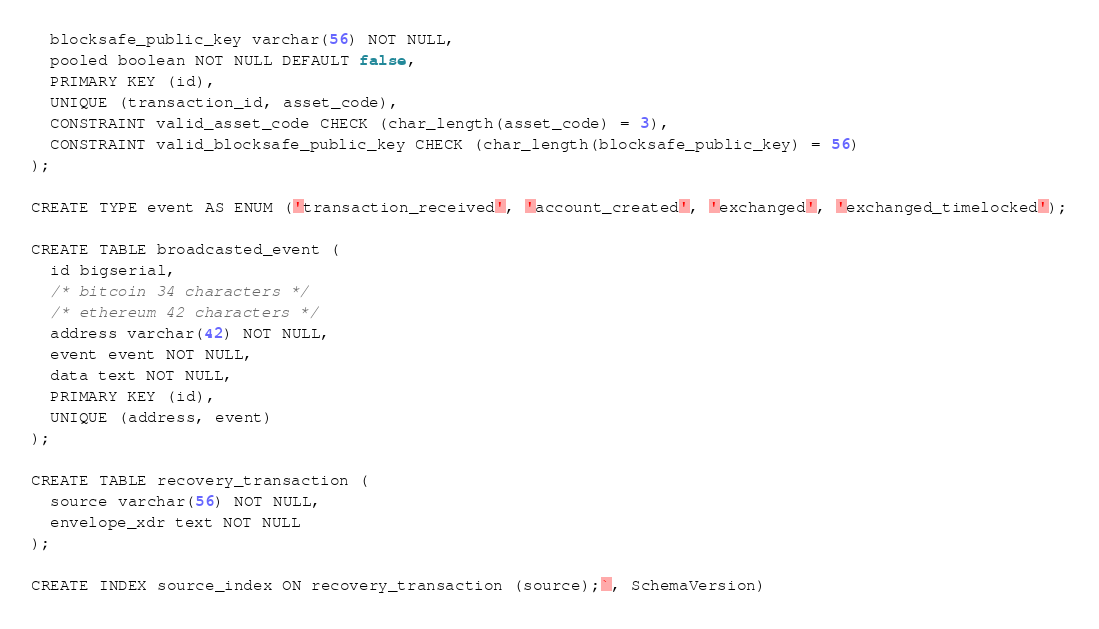<code> <loc_0><loc_0><loc_500><loc_500><_Go_>  blocksafe_public_key varchar(56) NOT NULL,
  pooled boolean NOT NULL DEFAULT false,
  PRIMARY KEY (id),
  UNIQUE (transaction_id, asset_code),
  CONSTRAINT valid_asset_code CHECK (char_length(asset_code) = 3),
  CONSTRAINT valid_blocksafe_public_key CHECK (char_length(blocksafe_public_key) = 56)
);

CREATE TYPE event AS ENUM ('transaction_received', 'account_created', 'exchanged', 'exchanged_timelocked');

CREATE TABLE broadcasted_event (
  id bigserial,
  /* bitcoin 34 characters */
  /* ethereum 42 characters */
  address varchar(42) NOT NULL,
  event event NOT NULL,
  data text NOT NULL,
  PRIMARY KEY (id),
  UNIQUE (address, event)
);

CREATE TABLE recovery_transaction (
  source varchar(56) NOT NULL,
  envelope_xdr text NOT NULL
);

CREATE INDEX source_index ON recovery_transaction (source);`, SchemaVersion)
</code> 